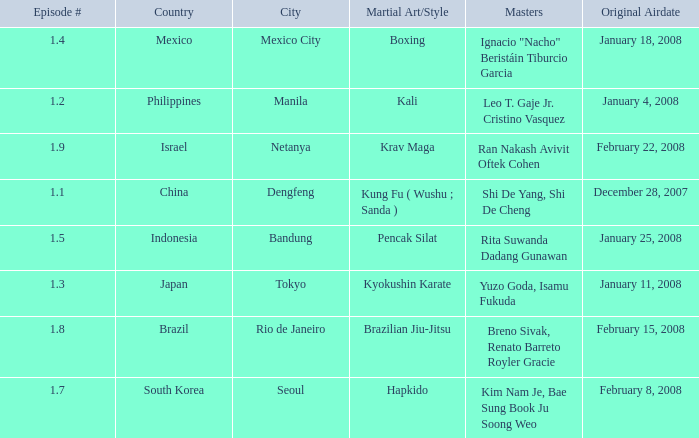How many masters fought using a boxing style? 1.0. 